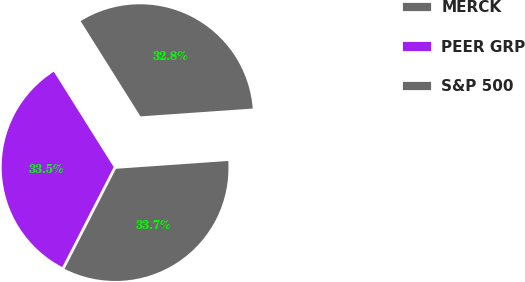Convert chart to OTSL. <chart><loc_0><loc_0><loc_500><loc_500><pie_chart><fcel>MERCK<fcel>PEER GRP<fcel>S&P 500<nl><fcel>32.82%<fcel>33.52%<fcel>33.66%<nl></chart> 